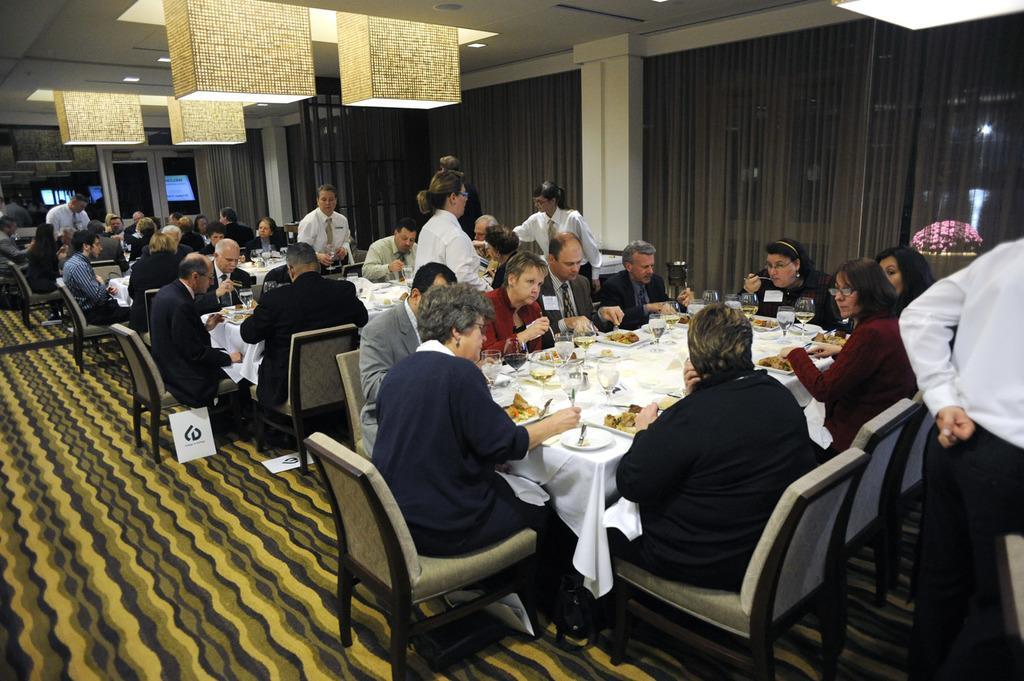Can you describe this image briefly? IN this picture we can see decorative ceiling lights. We can see few persons standing and few sitting on chairs in front of a table and having food and on the table we can see white clothes, glasses, plates of food. This is a floor. 